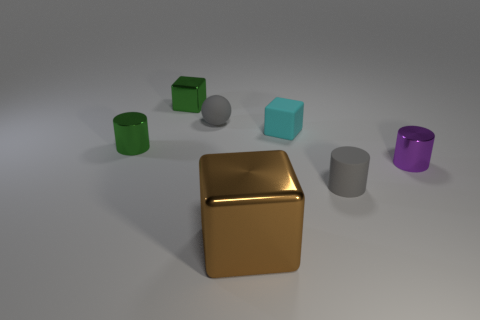Add 2 red cylinders. How many objects exist? 9 Subtract all cylinders. How many objects are left? 4 Subtract 0 purple balls. How many objects are left? 7 Subtract all blue matte cubes. Subtract all small shiny cylinders. How many objects are left? 5 Add 1 big objects. How many big objects are left? 2 Add 2 matte spheres. How many matte spheres exist? 3 